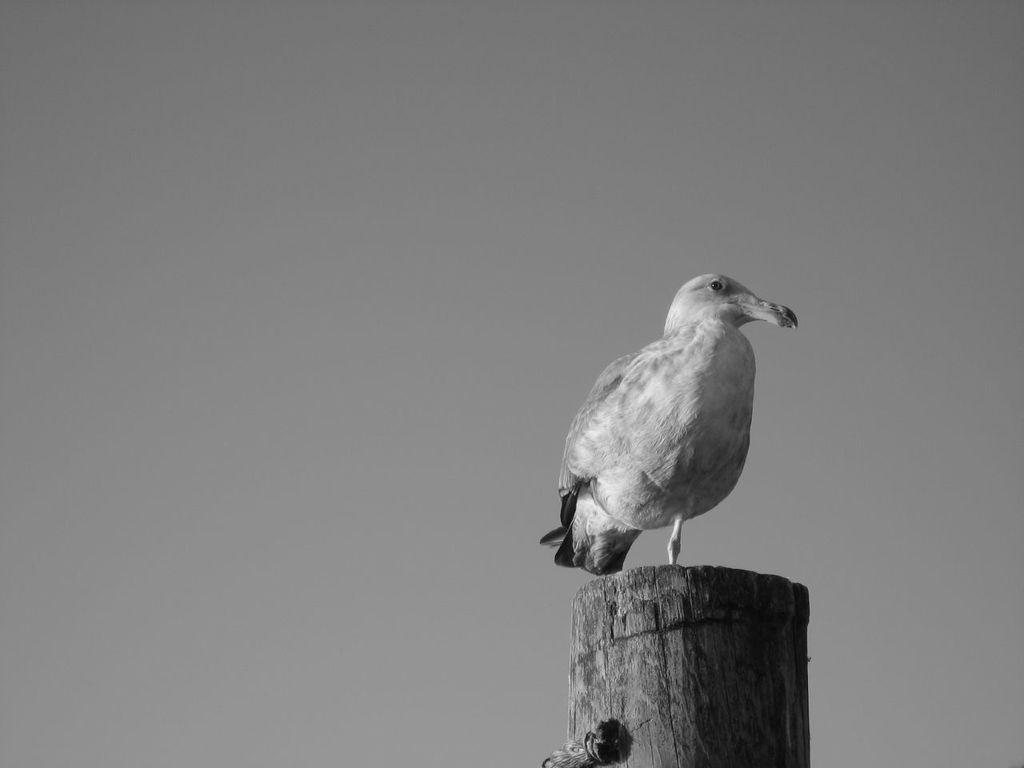What type of animal is in the image? There is a bird in the image. Where is the bird located? The bird is on a wooden block. What can be seen in the background of the image? The background of the image appears to be the sky. What is the reason for the protest in the image? There is no protest present in the image, as it features a bird on a wooden block with a sky background. 